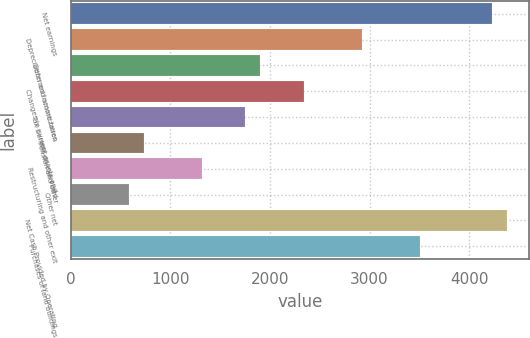Convert chart to OTSL. <chart><loc_0><loc_0><loc_500><loc_500><bar_chart><fcel>Net earnings<fcel>Depreciation and amortization<fcel>Deferred income taxes<fcel>Changes in current assets and<fcel>Tax benefit on exercised<fcel>Pension and other<fcel>Restructuring and other exit<fcel>Other net<fcel>Net Cash Provided by Operating<fcel>Purchases of land buildings<nl><fcel>4233.1<fcel>2920<fcel>1898.7<fcel>2336.4<fcel>1752.8<fcel>731.5<fcel>1315.1<fcel>585.6<fcel>4379<fcel>3503.6<nl></chart> 